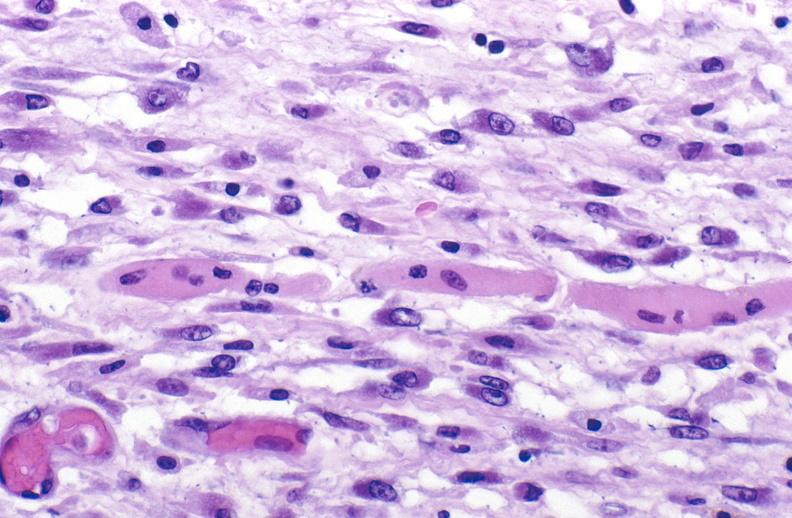s metastatic carcinoma oat cell present?
Answer the question using a single word or phrase. No 